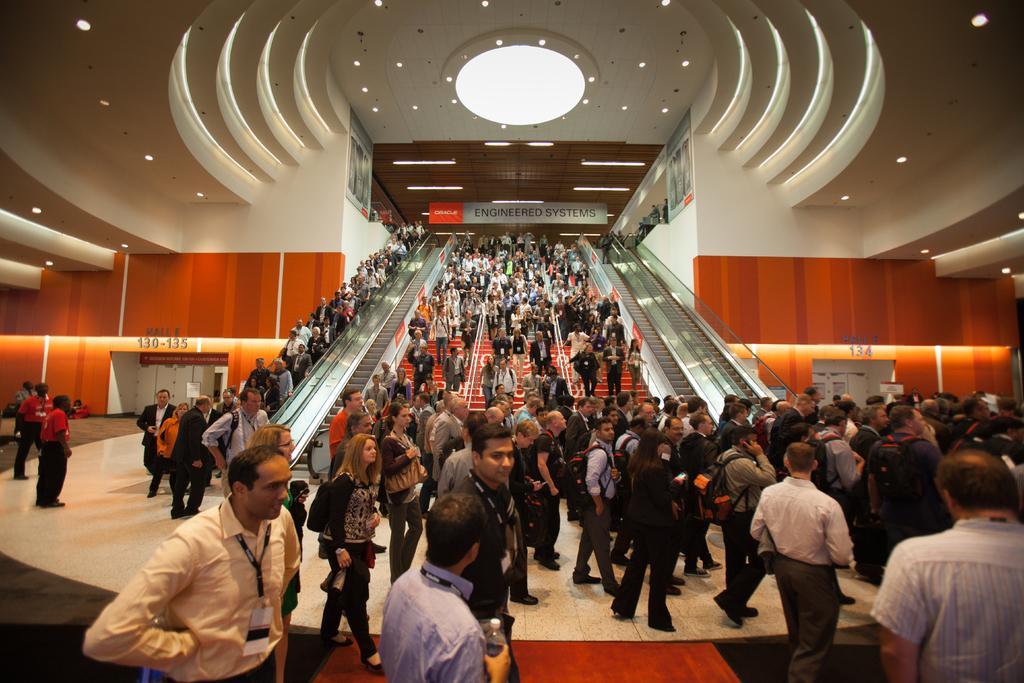How would you summarize this image in a sentence or two? In this picture I can see group of people standing, there are lights, boards, escalators, there are stairs, iron rods. 